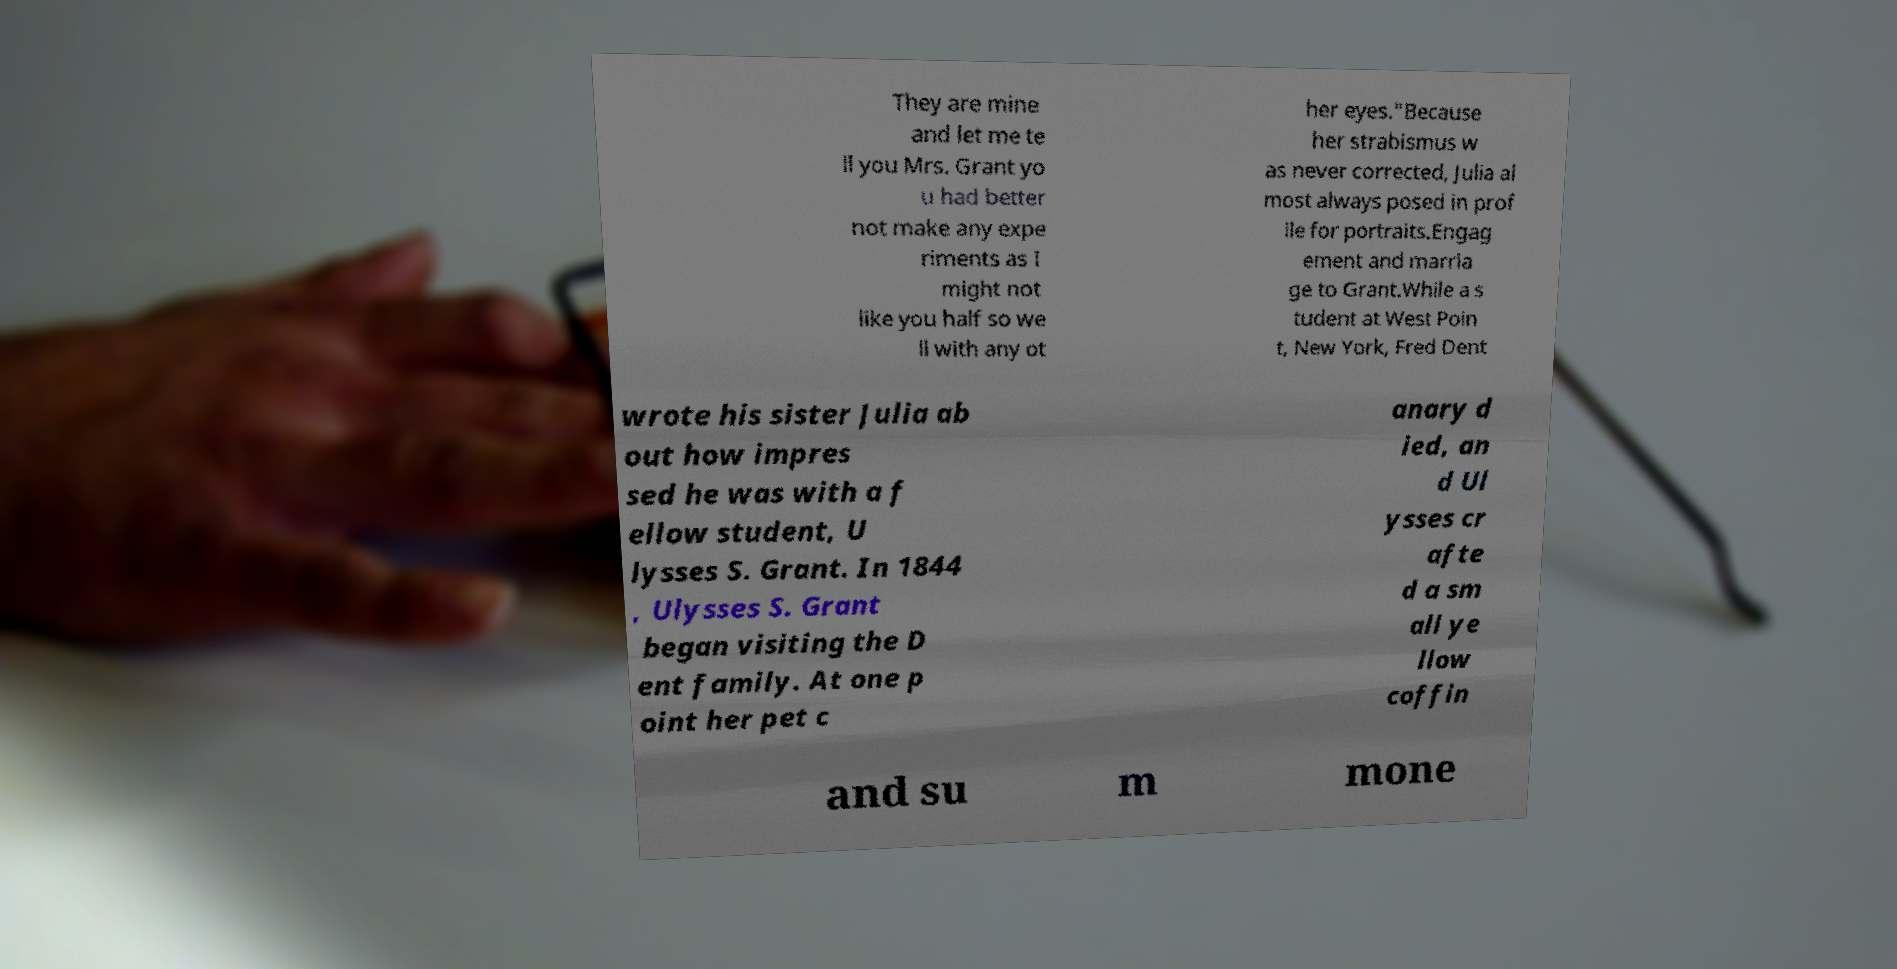There's text embedded in this image that I need extracted. Can you transcribe it verbatim? They are mine and let me te ll you Mrs. Grant yo u had better not make any expe riments as I might not like you half so we ll with any ot her eyes."Because her strabismus w as never corrected, Julia al most always posed in prof ile for portraits.Engag ement and marria ge to Grant.While a s tudent at West Poin t, New York, Fred Dent wrote his sister Julia ab out how impres sed he was with a f ellow student, U lysses S. Grant. In 1844 , Ulysses S. Grant began visiting the D ent family. At one p oint her pet c anary d ied, an d Ul ysses cr afte d a sm all ye llow coffin and su m mone 